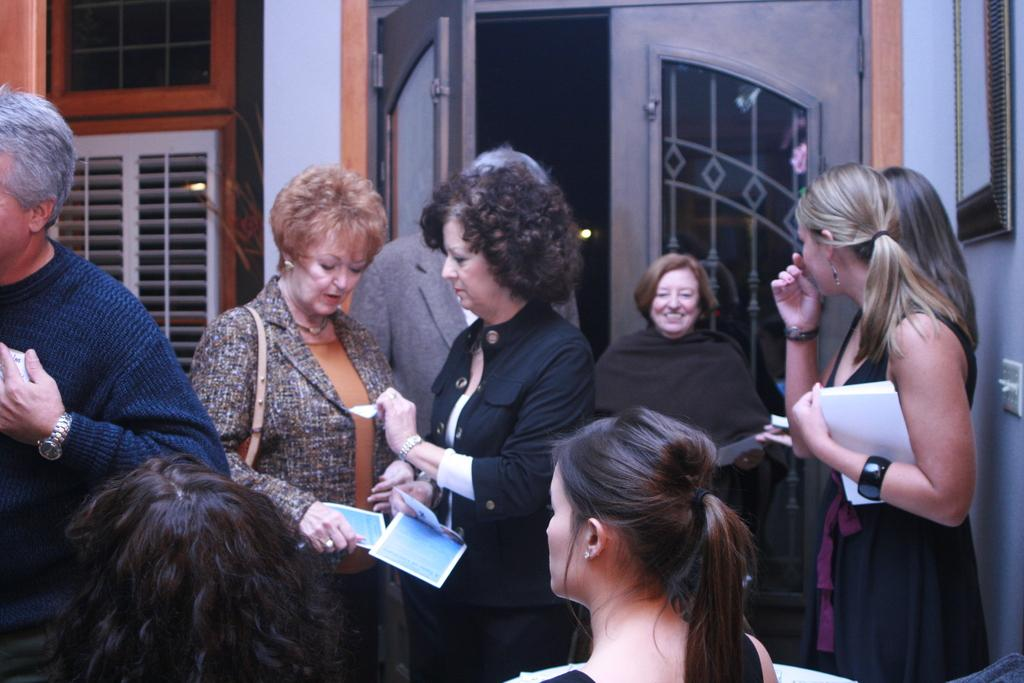How many people are in the image? There is a group of persons standing in the image. What is the surface they are standing on? The persons are standing on the floor. What can be seen in the background of the image? There is a window, a wall, a door, and a mirror in the background of the image. What type of oranges are being used as a hearing aid by the person on the left? There are no oranges or any hearing aids present in the image. 